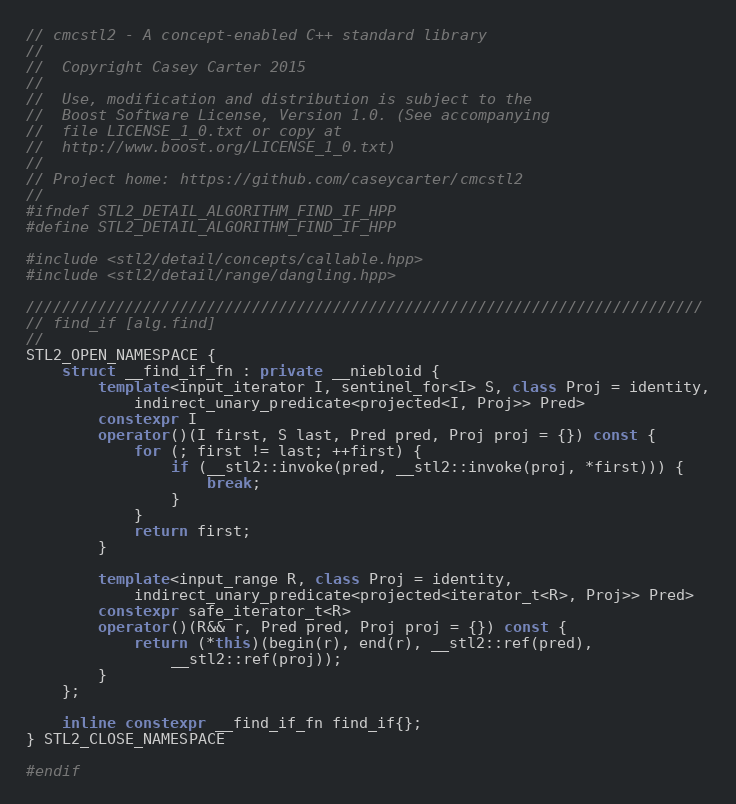Convert code to text. <code><loc_0><loc_0><loc_500><loc_500><_C++_>// cmcstl2 - A concept-enabled C++ standard library
//
//  Copyright Casey Carter 2015
//
//  Use, modification and distribution is subject to the
//  Boost Software License, Version 1.0. (See accompanying
//  file LICENSE_1_0.txt or copy at
//  http://www.boost.org/LICENSE_1_0.txt)
//
// Project home: https://github.com/caseycarter/cmcstl2
//
#ifndef STL2_DETAIL_ALGORITHM_FIND_IF_HPP
#define STL2_DETAIL_ALGORITHM_FIND_IF_HPP

#include <stl2/detail/concepts/callable.hpp>
#include <stl2/detail/range/dangling.hpp>

///////////////////////////////////////////////////////////////////////////
// find_if [alg.find]
//
STL2_OPEN_NAMESPACE {
	struct __find_if_fn : private __niebloid {
		template<input_iterator I, sentinel_for<I> S, class Proj = identity,
			indirect_unary_predicate<projected<I, Proj>> Pred>
		constexpr I
		operator()(I first, S last, Pred pred, Proj proj = {}) const {
			for (; first != last; ++first) {
				if (__stl2::invoke(pred, __stl2::invoke(proj, *first))) {
					break;
				}
			}
			return first;
		}

		template<input_range R, class Proj = identity,
			indirect_unary_predicate<projected<iterator_t<R>, Proj>> Pred>
		constexpr safe_iterator_t<R>
		operator()(R&& r, Pred pred, Proj proj = {}) const {
			return (*this)(begin(r), end(r), __stl2::ref(pred),
				__stl2::ref(proj));
		}
	};

	inline constexpr __find_if_fn find_if{};
} STL2_CLOSE_NAMESPACE

#endif
</code> 